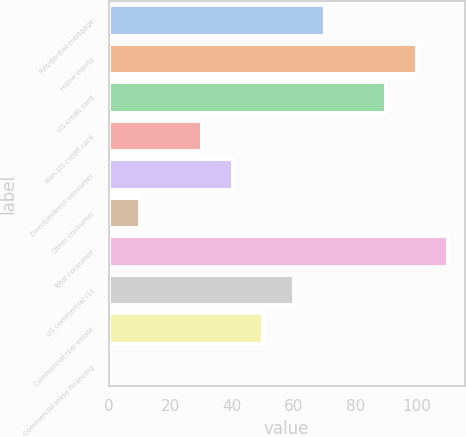<chart> <loc_0><loc_0><loc_500><loc_500><bar_chart><fcel>Residential mortgage<fcel>Home equity<fcel>US credit card<fcel>Non-US credit card<fcel>Direct/Indirect consumer<fcel>Other consumer<fcel>Total consumer<fcel>US commercial (1)<fcel>Commercial real estate<fcel>Commercial lease financing<nl><fcel>70.09<fcel>100<fcel>90.03<fcel>30.21<fcel>40.18<fcel>10.27<fcel>109.97<fcel>60.12<fcel>50.15<fcel>0.3<nl></chart> 